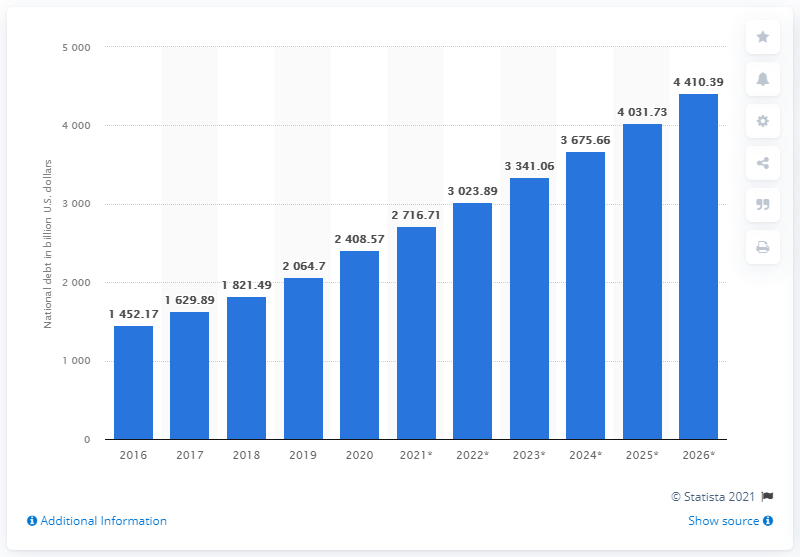Identify some key points in this picture. In 2020, the national debt of India was approximately 2408.57 dollars. 